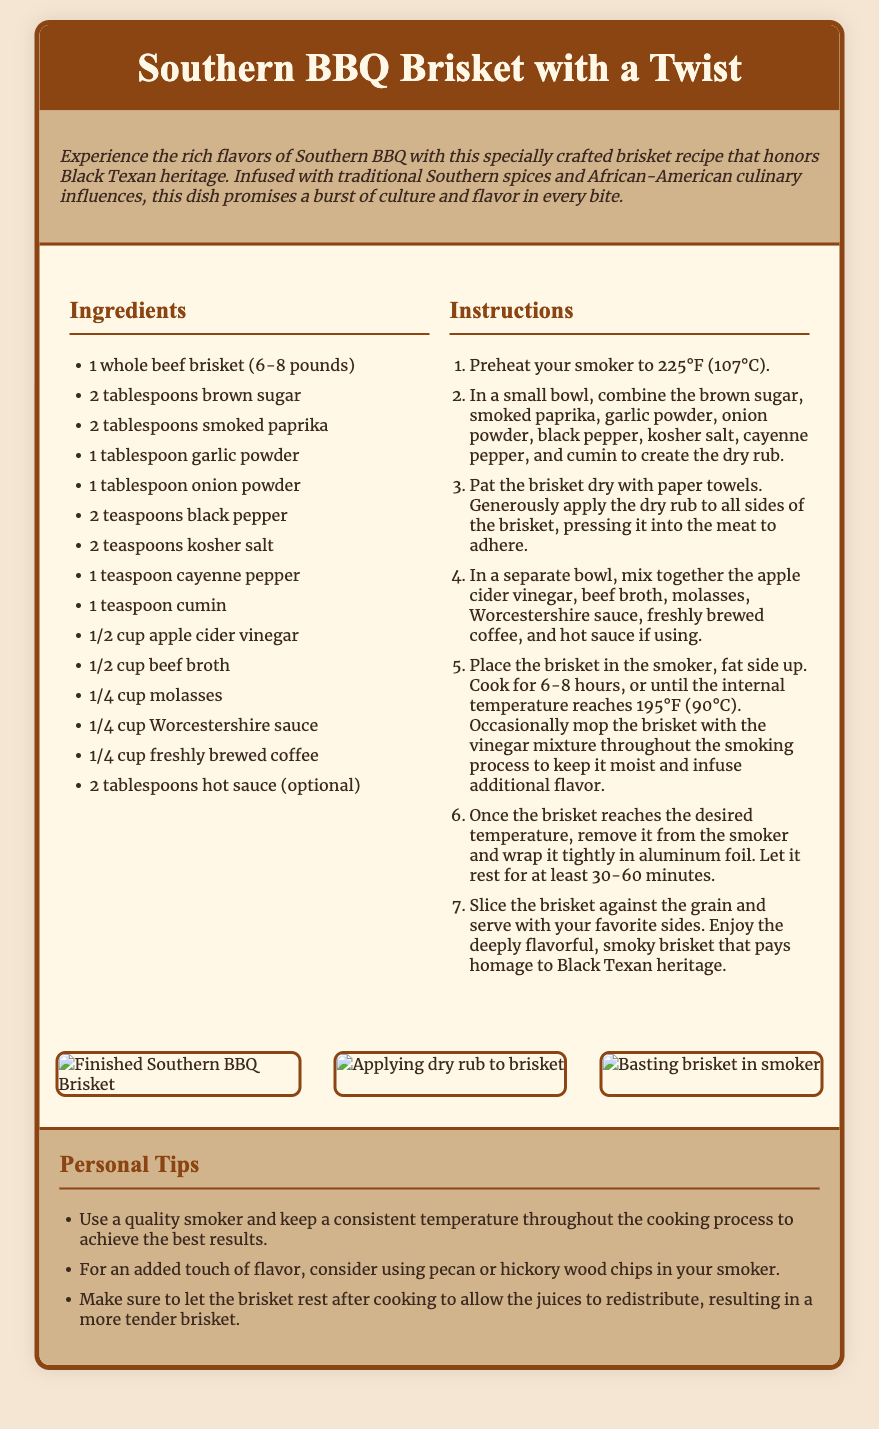What is the title of the recipe? The title is prominently displayed in the header section of the document.
Answer: Southern BBQ Brisket with a Twist How long should the brisket be cooked? The cooking time is specified in the instructions for the brisket.
Answer: 6-8 hours What is one optional ingredient for added flavor? The ingredients list includes both required and optional ingredients, highlighting the flexibility of the recipe.
Answer: Hot sauce What temperature should the smoker be preheated to? The initial step in the instructions clearly states the required temperature for smoking the brisket.
Answer: 225°F (107°C) What type of wood chips can enhance the flavor? This suggestion is found in the personal tips section regarding flavor enhancement during the smoking process.
Answer: Pecan or hickory How should the brisket be sliced for serving? The instructions detail the correct method for slicing the brisket.
Answer: Against the grain What is one key personal tip for ensuring a tender brisket? The personal tips section provides advice on cooking techniques that impact the brisket's texture.
Answer: Let the brisket rest What type of flavor does the recipe celebrate? The description at the beginning emphasizes the cultural significance of the dish.
Answer: Black Texan heritage 